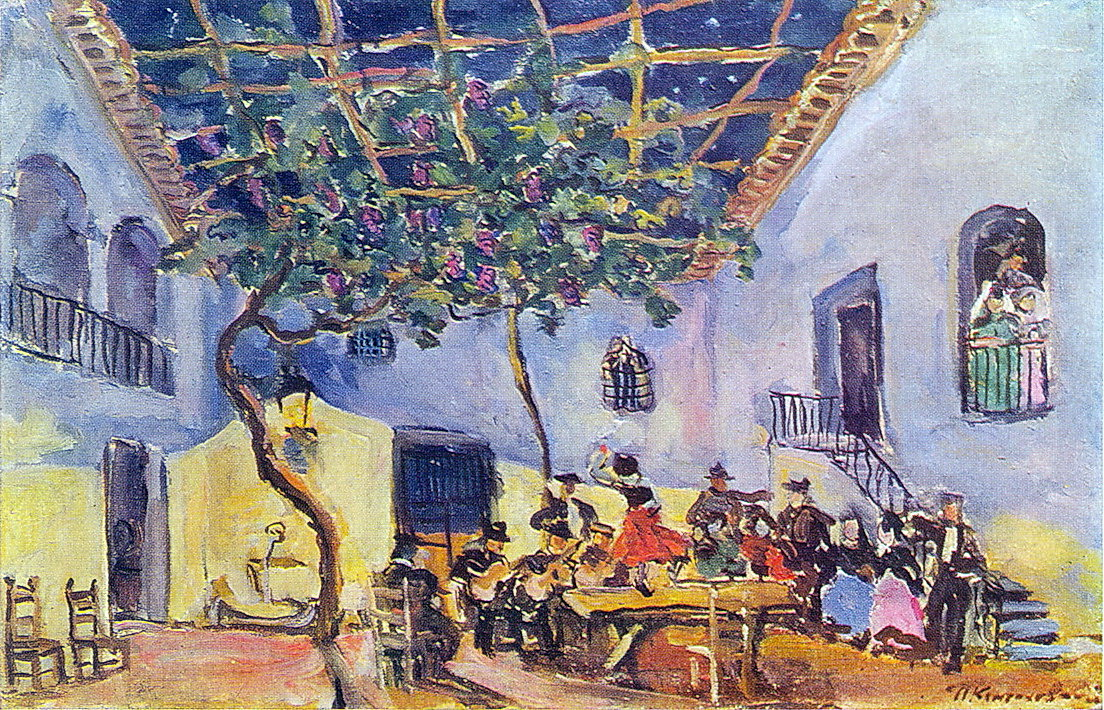What might be the significance of the tree in the painting? The tree in the painting could symbolize life and growth, standing prominently in the courtyard amidst the social gathering. Its branches laden with blossoms add a natural beauty to the scene, juxtaposed with the human activity below. The tree's presence also provides shade, creating a comfortable and inviting environment for the people gathered. In an impressionist context, the tree's representation with fluid and loose brushstrokes adds to the sense of movement and vibrancy in the painting.  Imagine the tree could speak. What stories might it tell about the people and events it has witnessed? If the tree could speak, it might share tales of countless gatherings and memorable moments it has witnessed over the years. It could recount how the courtyard has served as a backdrop for celebrations, heartfelt conversations, and perhaps even moments of solitude and reflection. The tree might tell stories of different generations of families who have enjoyed its shade and the laughter that has resonated through the leaves. It might also share insights into changes in fashion, culture, and social behaviors, providing a living history of the courtyard's life and the people who have passed through it. 